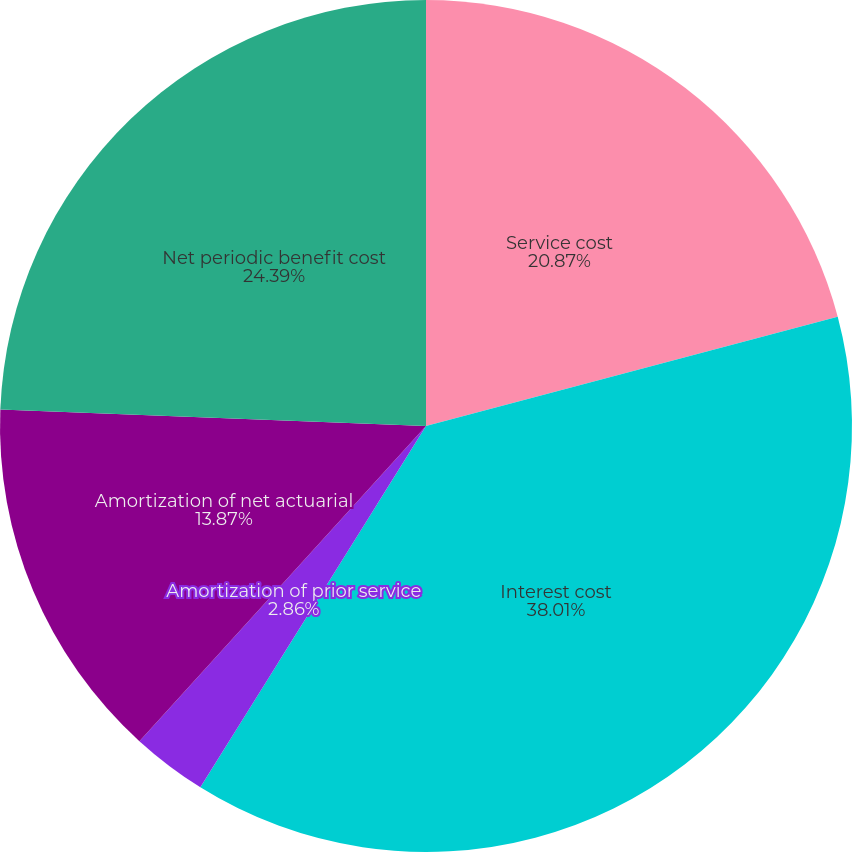Convert chart. <chart><loc_0><loc_0><loc_500><loc_500><pie_chart><fcel>Service cost<fcel>Interest cost<fcel>Amortization of prior service<fcel>Amortization of net actuarial<fcel>Net periodic benefit cost<nl><fcel>20.87%<fcel>38.02%<fcel>2.86%<fcel>13.87%<fcel>24.39%<nl></chart> 